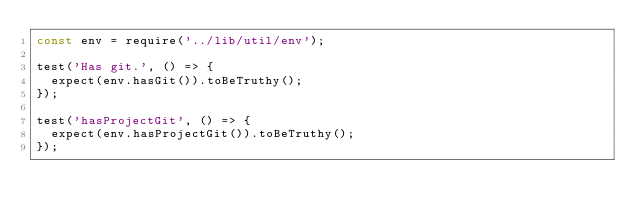<code> <loc_0><loc_0><loc_500><loc_500><_JavaScript_>const env = require('../lib/util/env');

test('Has git.', () => {
  expect(env.hasGit()).toBeTruthy();
});

test('hasProjectGit', () => {
  expect(env.hasProjectGit()).toBeTruthy();
});
</code> 